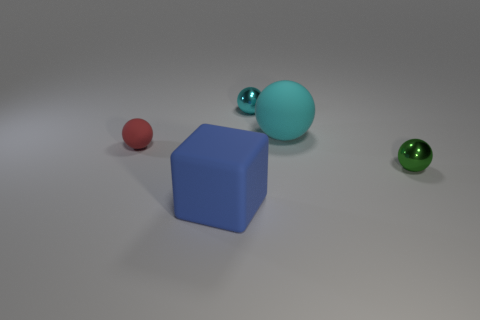Subtract all large matte cylinders. Subtract all red things. How many objects are left? 4 Add 2 tiny green metal spheres. How many tiny green metal spheres are left? 3 Add 5 cyan things. How many cyan things exist? 7 Add 5 small yellow things. How many objects exist? 10 Subtract all cyan balls. How many balls are left? 2 Subtract all big cyan balls. How many balls are left? 3 Subtract 0 brown cylinders. How many objects are left? 5 Subtract all balls. How many objects are left? 1 Subtract all brown spheres. Subtract all yellow cylinders. How many spheres are left? 4 Subtract all gray cylinders. How many green balls are left? 1 